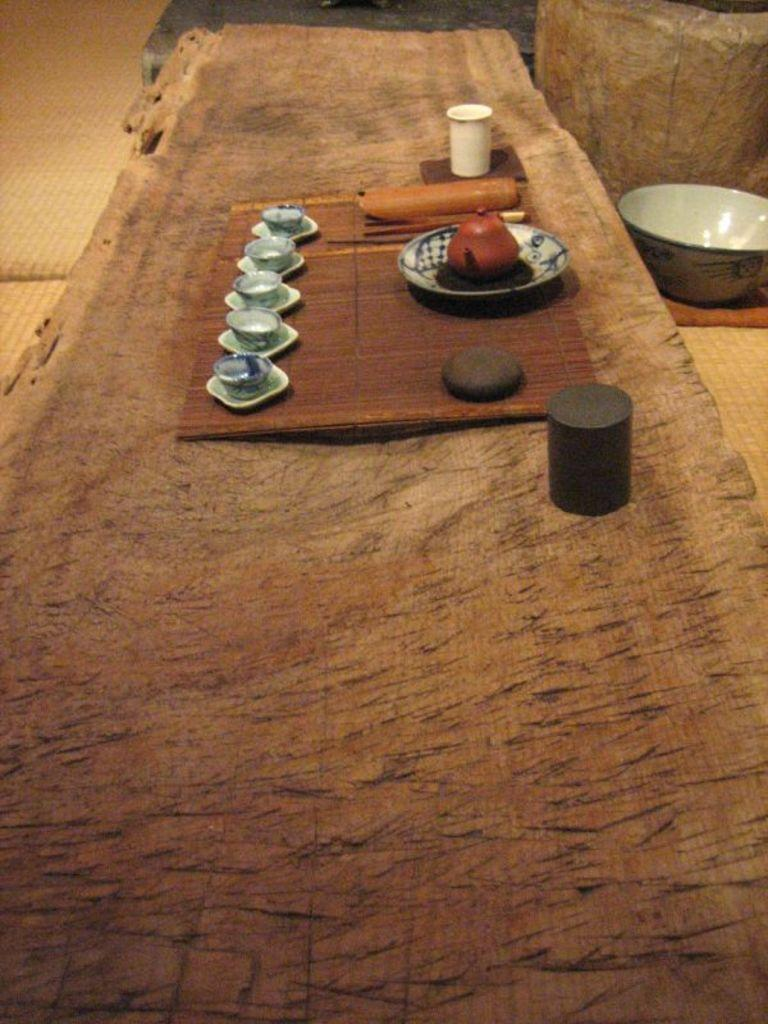How many porcelain cups are visible in the image? There are five porcelain cups in the image. What is the surface on which the cups are placed? The cups are placed on a wooden surface. What other dishware can be seen in the image besides the cups? There is a plate and a glass visible in the image. Where is the bowl located in the image? The bowl is on the right side of the image. What type of quince is being used as a decoration on the wooden surface? There is no quince present in the image; it only features porcelain cups, a plate, a glass, and a bowl. 